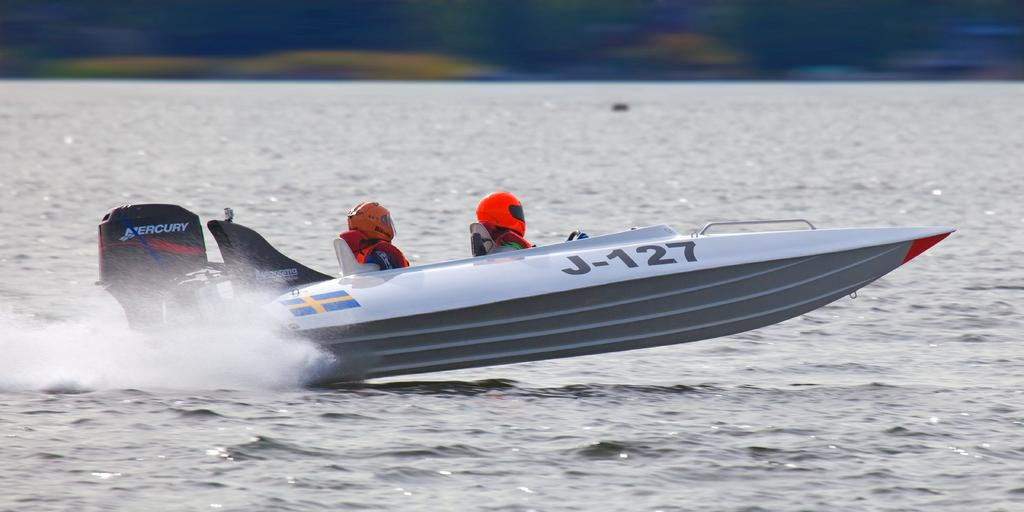<image>
Share a concise interpretation of the image provided. Two people with red helmets are sailing a speed boat with the text J127 on the right side of the boat. 